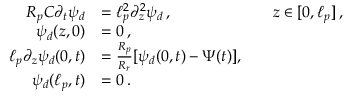Convert formula to latex. <formula><loc_0><loc_0><loc_500><loc_500>\begin{array} { r l r l } { R _ { p } C \partial _ { t } \psi _ { d } } & { = \ell _ { p } ^ { 2 } \partial _ { z } ^ { 2 } \psi _ { d } \, , } & & { z \in [ 0 , \ell _ { p } ] \, , } \\ { \psi _ { d } ( z , 0 ) } & { = 0 \, , } \\ { \ell _ { p } \partial _ { z } \psi _ { d } ( 0 , t ) } & { = \frac { R _ { p } } { R _ { r } } [ \psi _ { d } ( 0 , t ) - \Psi ( t ) ] , } \\ { \psi _ { d } ( \ell _ { p } , t ) } & { = 0 \, . } \end{array}</formula> 